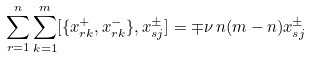Convert formula to latex. <formula><loc_0><loc_0><loc_500><loc_500>\sum _ { r = 1 } ^ { n } \sum _ { k = 1 } ^ { m } [ \{ x _ { r k } ^ { + } , x _ { r k } ^ { - } \} , x _ { s j } ^ { \pm } ] = \mp \nu \, n ( m - n ) x _ { s j } ^ { \pm }</formula> 